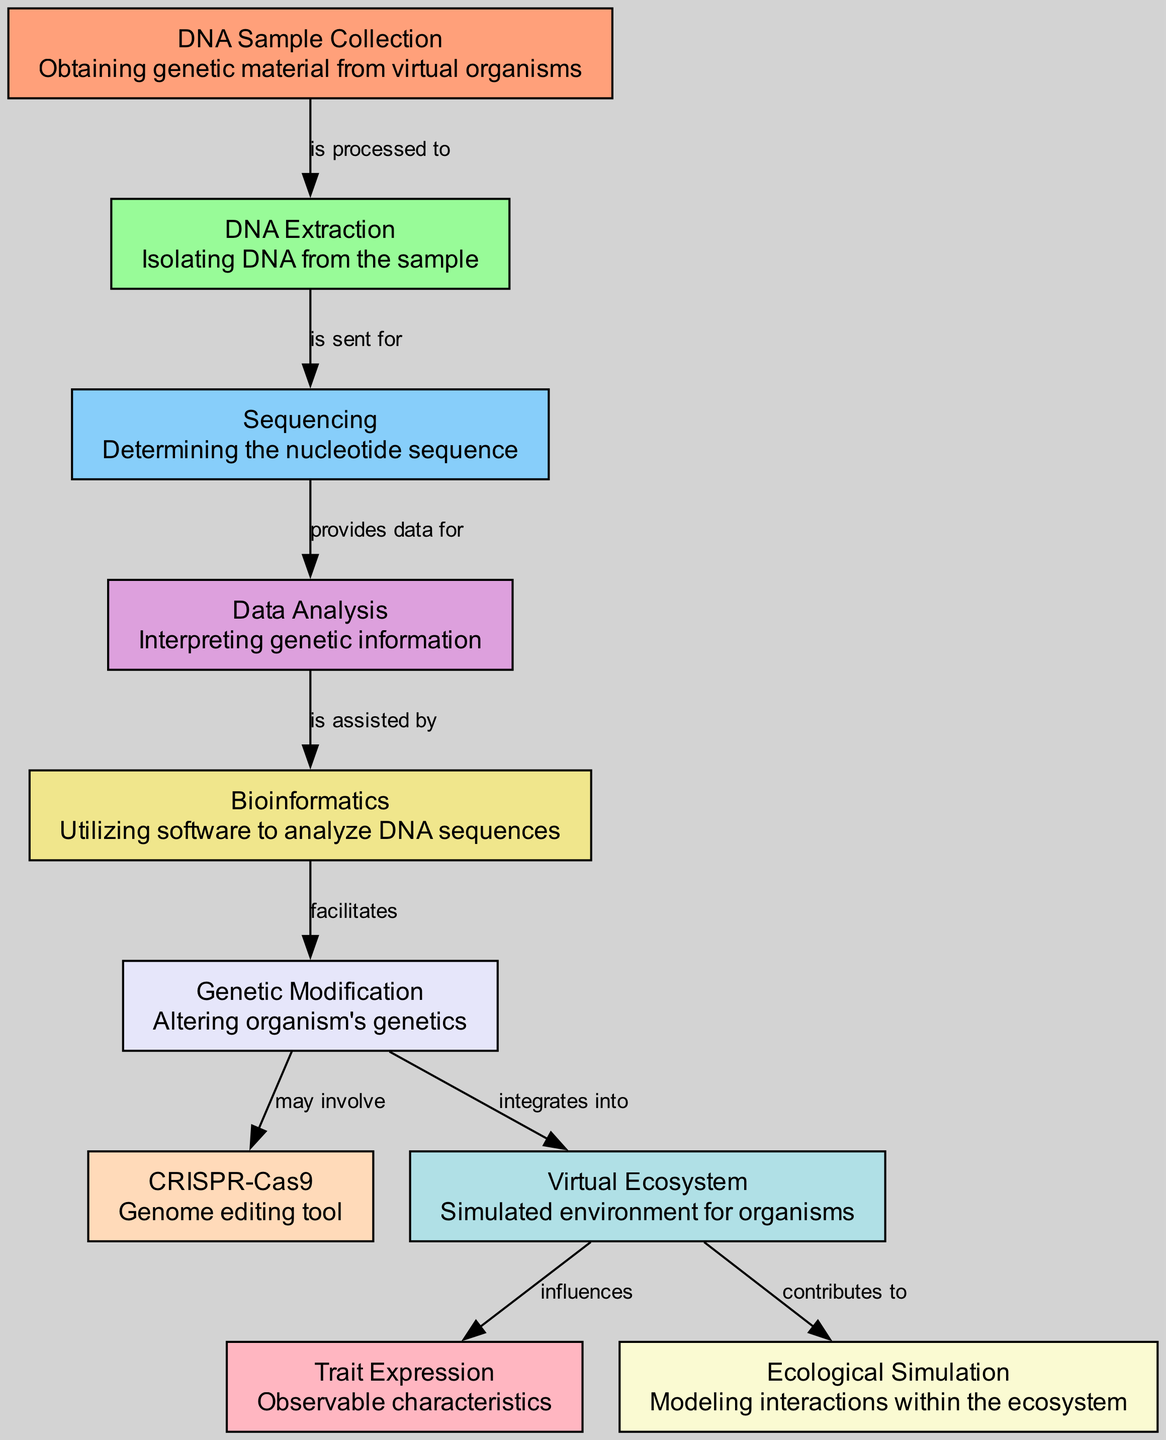What is the first step in the process? The diagram indicates the first step is "DNA Sample Collection," which involves obtaining genetic material from virtual organisms.
Answer: DNA Sample Collection How many nodes are in the diagram? By counting the entries in the nodes list, we find there are 10 nodes present in the diagram.
Answer: 10 What process occurs after DNA Extraction? According to the flow of the diagram, after "DNA Extraction," the next step is "Sequencing," which determines the nucleotide sequence.
Answer: Sequencing Which tool is involved in Genetic Modification? The diagram shows that "CRISPR-Cas9" is a genome editing tool that may be involved in the Genetic Modification process.
Answer: CRISPR-Cas9 What influences Trait Expression? The diagram states that the "Virtual Ecosystem" influences "Trait Expression," which refers to observable characteristics of organisms.
Answer: Virtual Ecosystem How does Data Analysis relate to Bioinformatics? The diagram indicates that "Data Analysis" is assisted by "Bioinformatics," meaning bioinformatics provides support in interpreting genetic information.
Answer: assisted by What is the role of the Virtual Ecosystem in ecological simulation? The diagram mentions that the "Virtual Ecosystem" contributes to "Ecological Simulation," modeling interactions within that ecosystem.
Answer: contributes to What is the last step in this process? Following the flow of the diagram, the last step discussed is that the Virtual Ecosystem contributes to Ecological Simulation, indicating it is the final noted process in the chain.
Answer: Ecological Simulation What facilitates Genetic Modification? The diagram specifies that "Bioinformatics" facilitates "Genetic Modification" by utilizing software to analyze DNA sequences.
Answer: facilitates 